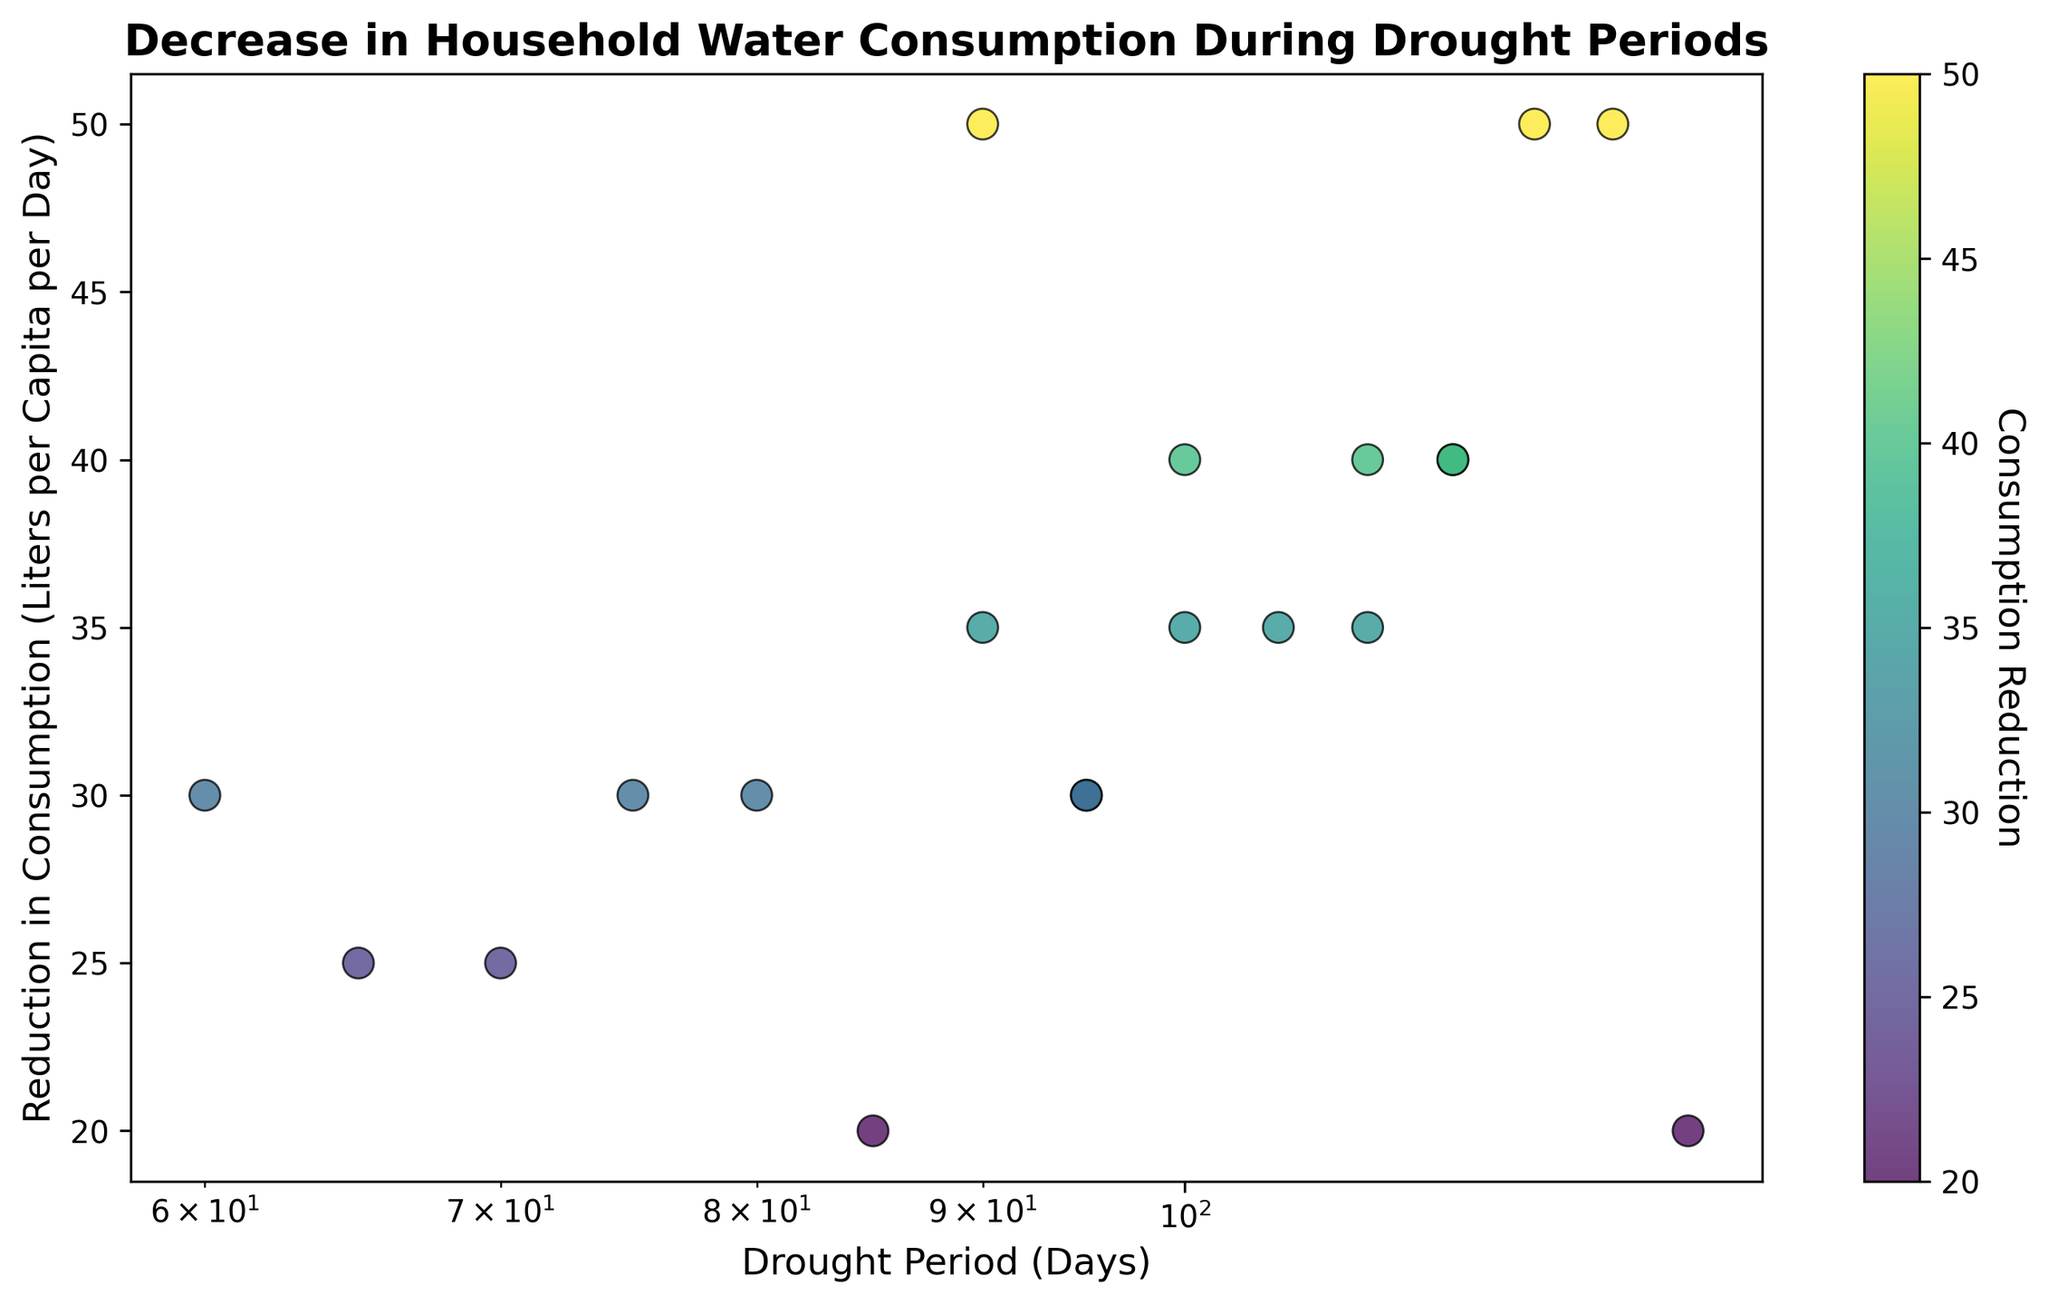What is the reduction in water consumption for Region A? We look at the point corresponding to Region A. The reduction is represented on the y-axis as 50 liters per capita per day.
Answer: 50 liters per capita per day Which region experienced the highest reduction in water consumption during the drought period? By looking at the scatter plot, Region H has the highest reduction shown by the point at the highest y-value, which is 50 liters per capita per day.
Answer: Region H Which regions have a drought period longer than 100 days? Points corresponding to regions with drought periods longer than 100 days show higher x-values. Regions that fit this criterion are Regions B, E, F, H, K, L, R, and S.
Answer: Regions B, E, F, H, K, L, R, S For regions with a consumption reduction of 40 liters per capita per day, what is the range of their drought periods? Points with a reduction of 40 liters per capita per day lie horizontally together. By observing the x-axis values, the range is from approximately 90 days to 115 days, covering Regions D, G, P, and T.
Answer: 90 to 115 days Which region has the least reduction in water consumption and what is the value? The point with the lowest y-value indicates the region with the least reduction. This is Region F with a reduction of 20 liters per capita per day.
Answer: Region F, 20 liters per capita per day Compare the water consumption reduction between Region I and Region T. Who had more reduction and by how much? Region I has a reduction of 25 liters per capita per day, and Region T has 30 liters per capita per day. Comparing these, Region T has 5 liters more reduction than Region I.
Answer: Region T, by 5 liters per capita per day Identify the median consumption reduction from the provided data points. To find the median, we order the reductions: 5, 10, 15, ..., 30, 35, 40, ..., 50. With 20 data points, the median is the average of the 10th and 11th values, which both are 30. Thus, the median is 30 liters per capita per day.
Answer: 30 liters per capita per day Which region had the shortest drought period, and what was its reduction in water consumption? The region with the shortest drought period (60 days) is Region C. Its reduction in consumption is 30 liters per capita per day.
Answer: Region C, 30 liters per capita per day What is the average reduction in water consumption across all regions? Summing the reductions: 50 + 50 + 30 + 40 + 40 + 20 + 30 + 50 + 25 + 30 + 40 + 35 + 20 + 30 + 25 + 35 + 35 + 35 + 40 + 30 = 705. Dividing this by the 20 regions, we get an average reduction of 35.25 liters per capita per day.
Answer: 35.25 liters per capita per day 